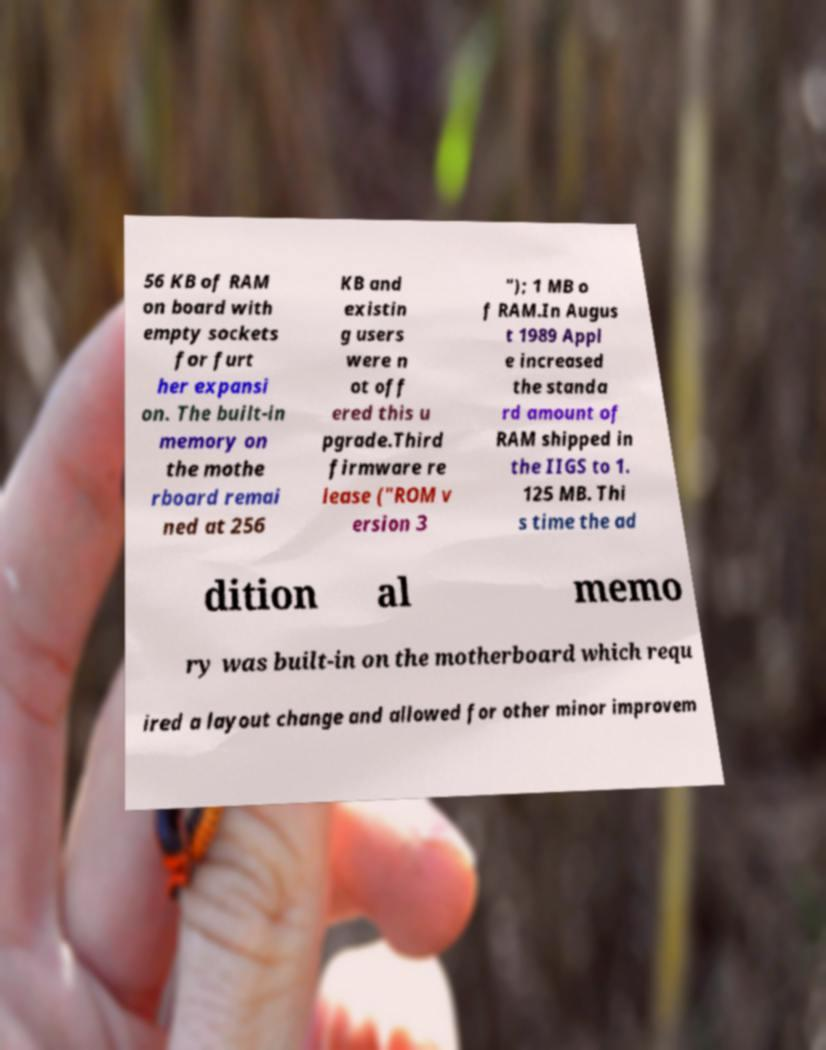Please identify and transcribe the text found in this image. 56 KB of RAM on board with empty sockets for furt her expansi on. The built-in memory on the mothe rboard remai ned at 256 KB and existin g users were n ot off ered this u pgrade.Third firmware re lease ("ROM v ersion 3 "); 1 MB o f RAM.In Augus t 1989 Appl e increased the standa rd amount of RAM shipped in the IIGS to 1. 125 MB. Thi s time the ad dition al memo ry was built-in on the motherboard which requ ired a layout change and allowed for other minor improvem 